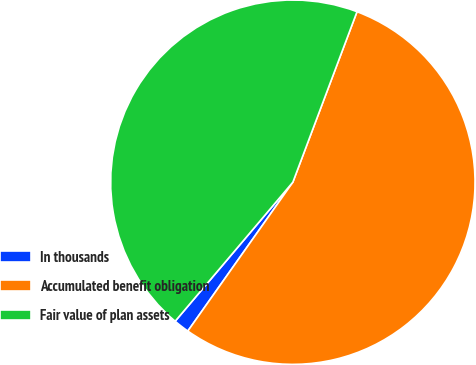<chart> <loc_0><loc_0><loc_500><loc_500><pie_chart><fcel>In thousands<fcel>Accumulated benefit obligation<fcel>Fair value of plan assets<nl><fcel>1.4%<fcel>54.05%<fcel>44.55%<nl></chart> 